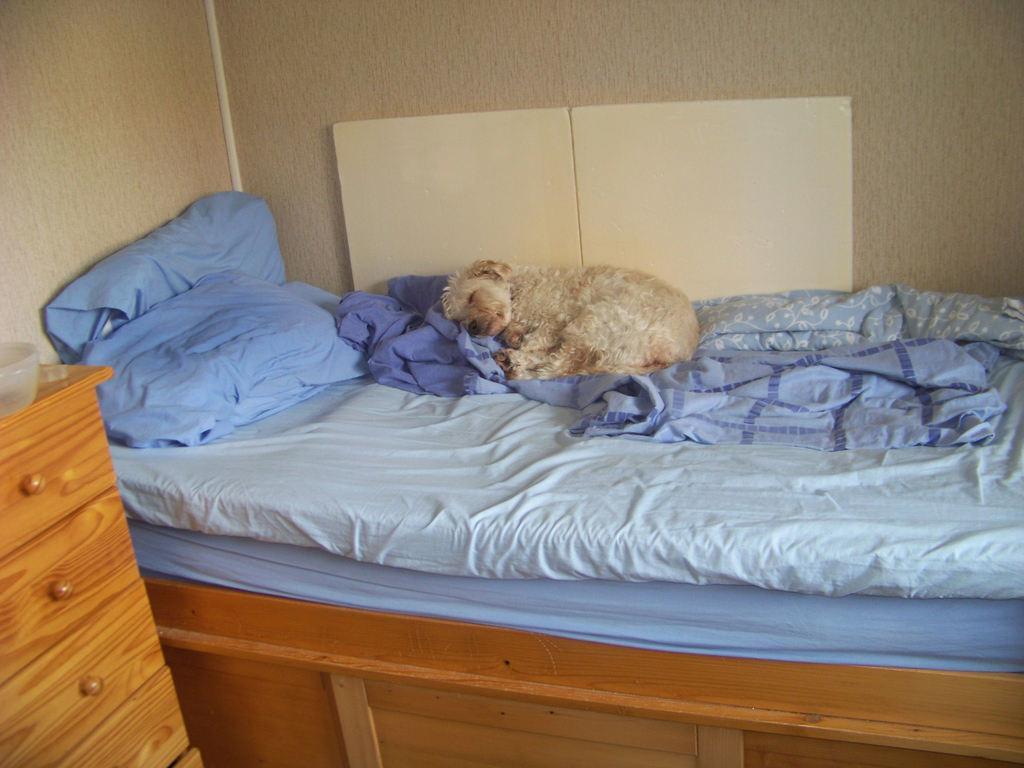Describe this image in one or two sentences. In the image there is a bed with blue blanket and blue pillows. A dog is lying on the bed. Towards the left there is a cupboard and a bowl on it. In the background there is a wall. 